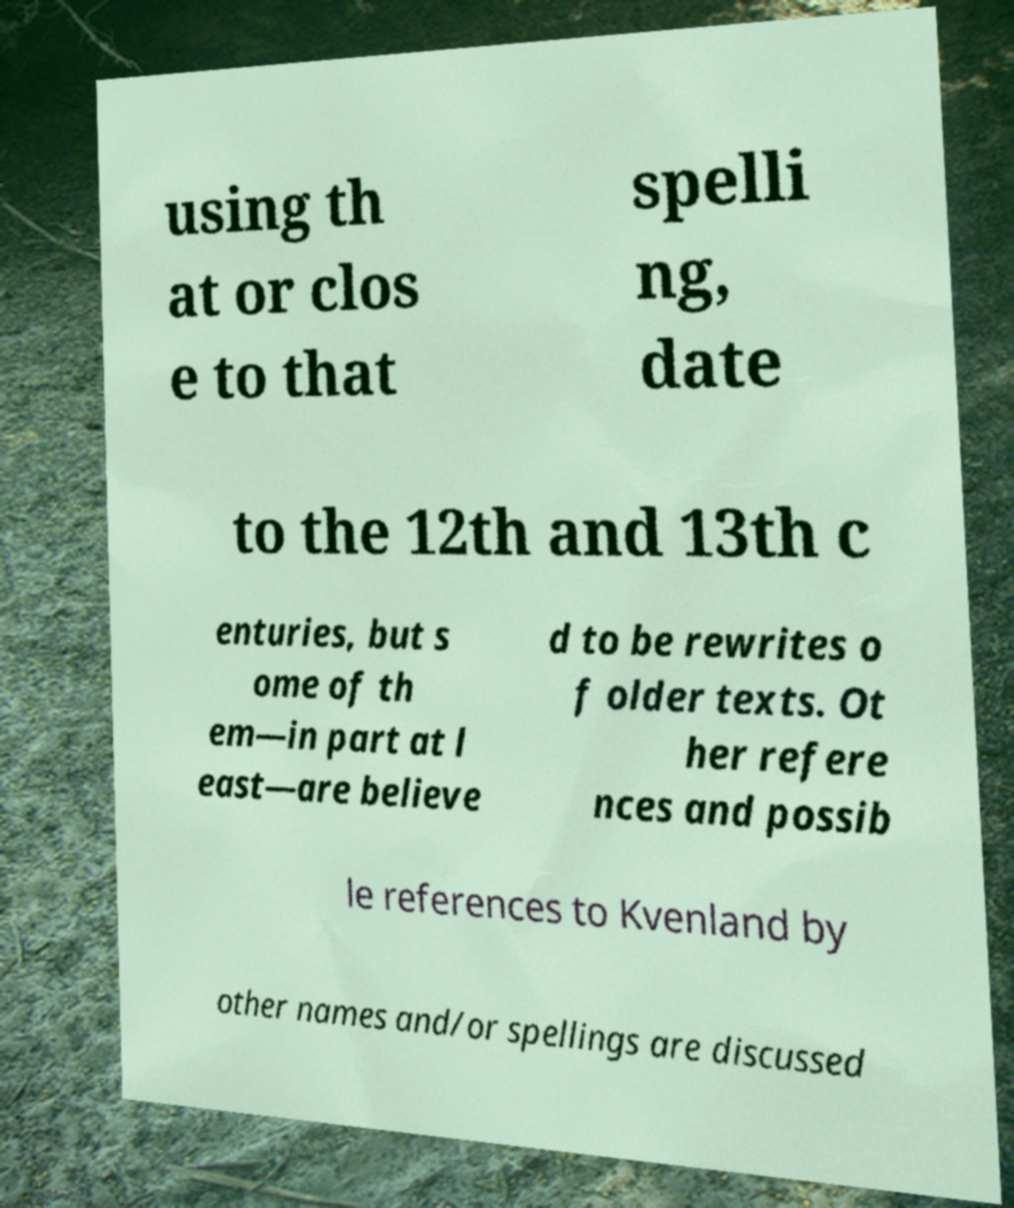Please read and relay the text visible in this image. What does it say? using th at or clos e to that spelli ng, date to the 12th and 13th c enturies, but s ome of th em—in part at l east—are believe d to be rewrites o f older texts. Ot her refere nces and possib le references to Kvenland by other names and/or spellings are discussed 